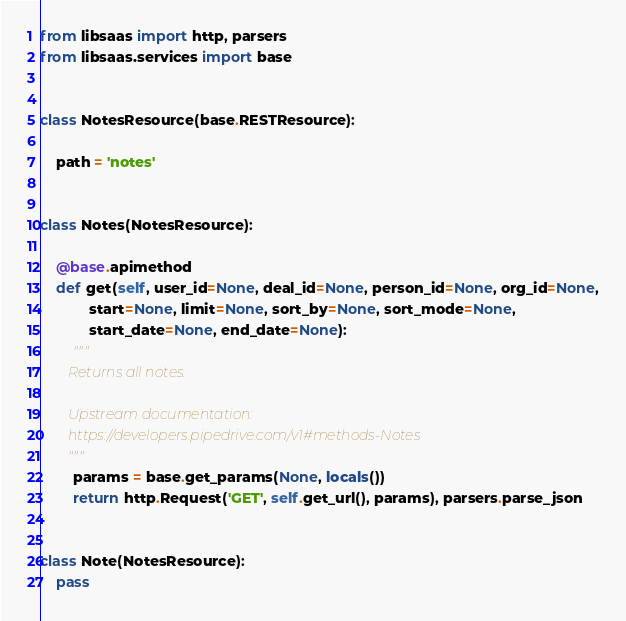<code> <loc_0><loc_0><loc_500><loc_500><_Python_>from libsaas import http, parsers
from libsaas.services import base


class NotesResource(base.RESTResource):

    path = 'notes'


class Notes(NotesResource):

    @base.apimethod
    def get(self, user_id=None, deal_id=None, person_id=None, org_id=None,
            start=None, limit=None, sort_by=None, sort_mode=None,
            start_date=None, end_date=None):
        """
        Returns all notes.

        Upstream documentation:
        https://developers.pipedrive.com/v1#methods-Notes
        """
        params = base.get_params(None, locals())
        return http.Request('GET', self.get_url(), params), parsers.parse_json


class Note(NotesResource):
    pass</code> 